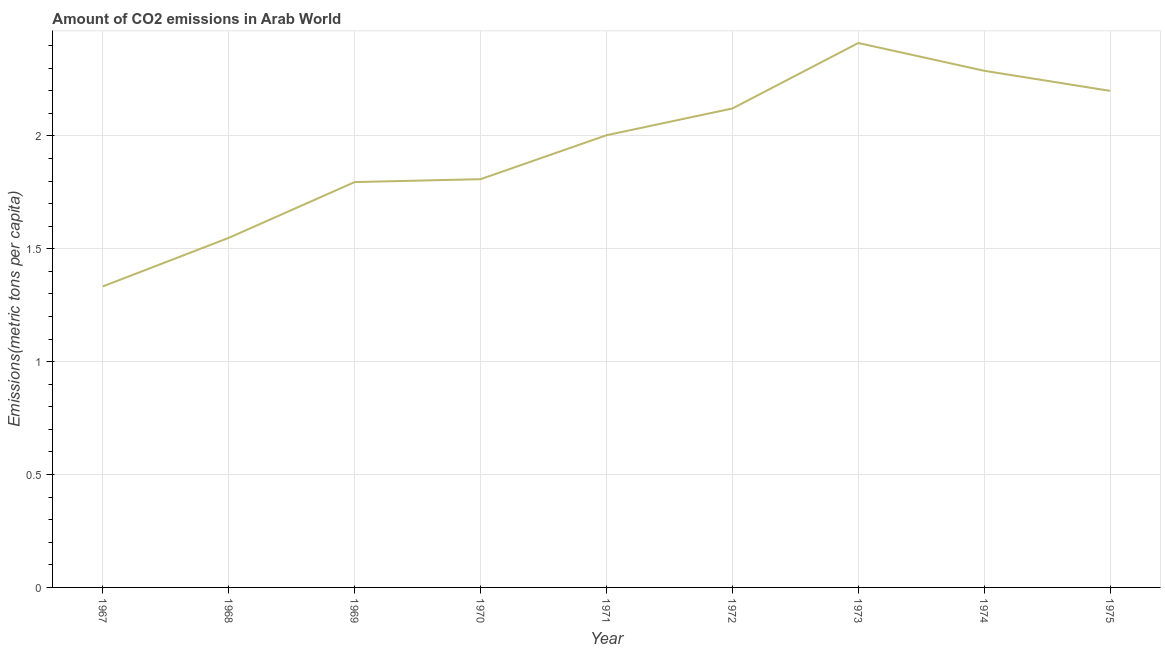What is the amount of co2 emissions in 1969?
Ensure brevity in your answer.  1.8. Across all years, what is the maximum amount of co2 emissions?
Keep it short and to the point. 2.41. Across all years, what is the minimum amount of co2 emissions?
Ensure brevity in your answer.  1.33. In which year was the amount of co2 emissions minimum?
Provide a succinct answer. 1967. What is the sum of the amount of co2 emissions?
Offer a terse response. 17.51. What is the difference between the amount of co2 emissions in 1972 and 1975?
Ensure brevity in your answer.  -0.08. What is the average amount of co2 emissions per year?
Ensure brevity in your answer.  1.95. What is the median amount of co2 emissions?
Your answer should be very brief. 2. In how many years, is the amount of co2 emissions greater than 1 metric tons per capita?
Your response must be concise. 9. What is the ratio of the amount of co2 emissions in 1970 to that in 1972?
Your answer should be compact. 0.85. Is the difference between the amount of co2 emissions in 1969 and 1970 greater than the difference between any two years?
Your answer should be compact. No. What is the difference between the highest and the second highest amount of co2 emissions?
Make the answer very short. 0.12. Is the sum of the amount of co2 emissions in 1967 and 1968 greater than the maximum amount of co2 emissions across all years?
Make the answer very short. Yes. What is the difference between the highest and the lowest amount of co2 emissions?
Provide a succinct answer. 1.08. In how many years, is the amount of co2 emissions greater than the average amount of co2 emissions taken over all years?
Provide a short and direct response. 5. Does the amount of co2 emissions monotonically increase over the years?
Make the answer very short. No. What is the difference between two consecutive major ticks on the Y-axis?
Offer a very short reply. 0.5. Does the graph contain grids?
Give a very brief answer. Yes. What is the title of the graph?
Provide a short and direct response. Amount of CO2 emissions in Arab World. What is the label or title of the X-axis?
Make the answer very short. Year. What is the label or title of the Y-axis?
Offer a very short reply. Emissions(metric tons per capita). What is the Emissions(metric tons per capita) in 1967?
Your response must be concise. 1.33. What is the Emissions(metric tons per capita) of 1968?
Your answer should be very brief. 1.55. What is the Emissions(metric tons per capita) in 1969?
Give a very brief answer. 1.8. What is the Emissions(metric tons per capita) of 1970?
Ensure brevity in your answer.  1.81. What is the Emissions(metric tons per capita) of 1971?
Make the answer very short. 2. What is the Emissions(metric tons per capita) in 1972?
Your response must be concise. 2.12. What is the Emissions(metric tons per capita) of 1973?
Provide a succinct answer. 2.41. What is the Emissions(metric tons per capita) of 1974?
Your answer should be compact. 2.29. What is the Emissions(metric tons per capita) in 1975?
Give a very brief answer. 2.2. What is the difference between the Emissions(metric tons per capita) in 1967 and 1968?
Make the answer very short. -0.22. What is the difference between the Emissions(metric tons per capita) in 1967 and 1969?
Keep it short and to the point. -0.46. What is the difference between the Emissions(metric tons per capita) in 1967 and 1970?
Provide a short and direct response. -0.47. What is the difference between the Emissions(metric tons per capita) in 1967 and 1971?
Provide a short and direct response. -0.67. What is the difference between the Emissions(metric tons per capita) in 1967 and 1972?
Give a very brief answer. -0.79. What is the difference between the Emissions(metric tons per capita) in 1967 and 1973?
Keep it short and to the point. -1.08. What is the difference between the Emissions(metric tons per capita) in 1967 and 1974?
Your answer should be very brief. -0.96. What is the difference between the Emissions(metric tons per capita) in 1967 and 1975?
Your response must be concise. -0.87. What is the difference between the Emissions(metric tons per capita) in 1968 and 1969?
Provide a short and direct response. -0.25. What is the difference between the Emissions(metric tons per capita) in 1968 and 1970?
Your response must be concise. -0.26. What is the difference between the Emissions(metric tons per capita) in 1968 and 1971?
Your answer should be very brief. -0.45. What is the difference between the Emissions(metric tons per capita) in 1968 and 1972?
Offer a very short reply. -0.57. What is the difference between the Emissions(metric tons per capita) in 1968 and 1973?
Offer a terse response. -0.86. What is the difference between the Emissions(metric tons per capita) in 1968 and 1974?
Your answer should be compact. -0.74. What is the difference between the Emissions(metric tons per capita) in 1968 and 1975?
Keep it short and to the point. -0.65. What is the difference between the Emissions(metric tons per capita) in 1969 and 1970?
Offer a terse response. -0.01. What is the difference between the Emissions(metric tons per capita) in 1969 and 1971?
Provide a short and direct response. -0.21. What is the difference between the Emissions(metric tons per capita) in 1969 and 1972?
Give a very brief answer. -0.33. What is the difference between the Emissions(metric tons per capita) in 1969 and 1973?
Ensure brevity in your answer.  -0.62. What is the difference between the Emissions(metric tons per capita) in 1969 and 1974?
Give a very brief answer. -0.49. What is the difference between the Emissions(metric tons per capita) in 1969 and 1975?
Ensure brevity in your answer.  -0.4. What is the difference between the Emissions(metric tons per capita) in 1970 and 1971?
Your answer should be very brief. -0.19. What is the difference between the Emissions(metric tons per capita) in 1970 and 1972?
Offer a very short reply. -0.31. What is the difference between the Emissions(metric tons per capita) in 1970 and 1973?
Provide a short and direct response. -0.6. What is the difference between the Emissions(metric tons per capita) in 1970 and 1974?
Your response must be concise. -0.48. What is the difference between the Emissions(metric tons per capita) in 1970 and 1975?
Keep it short and to the point. -0.39. What is the difference between the Emissions(metric tons per capita) in 1971 and 1972?
Provide a short and direct response. -0.12. What is the difference between the Emissions(metric tons per capita) in 1971 and 1973?
Keep it short and to the point. -0.41. What is the difference between the Emissions(metric tons per capita) in 1971 and 1974?
Ensure brevity in your answer.  -0.29. What is the difference between the Emissions(metric tons per capita) in 1971 and 1975?
Ensure brevity in your answer.  -0.2. What is the difference between the Emissions(metric tons per capita) in 1972 and 1973?
Your response must be concise. -0.29. What is the difference between the Emissions(metric tons per capita) in 1972 and 1974?
Offer a very short reply. -0.17. What is the difference between the Emissions(metric tons per capita) in 1972 and 1975?
Give a very brief answer. -0.08. What is the difference between the Emissions(metric tons per capita) in 1973 and 1974?
Provide a succinct answer. 0.12. What is the difference between the Emissions(metric tons per capita) in 1973 and 1975?
Make the answer very short. 0.21. What is the difference between the Emissions(metric tons per capita) in 1974 and 1975?
Offer a terse response. 0.09. What is the ratio of the Emissions(metric tons per capita) in 1967 to that in 1968?
Your answer should be very brief. 0.86. What is the ratio of the Emissions(metric tons per capita) in 1967 to that in 1969?
Provide a succinct answer. 0.74. What is the ratio of the Emissions(metric tons per capita) in 1967 to that in 1970?
Your response must be concise. 0.74. What is the ratio of the Emissions(metric tons per capita) in 1967 to that in 1971?
Offer a very short reply. 0.67. What is the ratio of the Emissions(metric tons per capita) in 1967 to that in 1972?
Offer a very short reply. 0.63. What is the ratio of the Emissions(metric tons per capita) in 1967 to that in 1973?
Offer a very short reply. 0.55. What is the ratio of the Emissions(metric tons per capita) in 1967 to that in 1974?
Provide a short and direct response. 0.58. What is the ratio of the Emissions(metric tons per capita) in 1967 to that in 1975?
Offer a terse response. 0.61. What is the ratio of the Emissions(metric tons per capita) in 1968 to that in 1969?
Offer a terse response. 0.86. What is the ratio of the Emissions(metric tons per capita) in 1968 to that in 1970?
Your answer should be very brief. 0.86. What is the ratio of the Emissions(metric tons per capita) in 1968 to that in 1971?
Offer a terse response. 0.77. What is the ratio of the Emissions(metric tons per capita) in 1968 to that in 1972?
Your answer should be very brief. 0.73. What is the ratio of the Emissions(metric tons per capita) in 1968 to that in 1973?
Make the answer very short. 0.64. What is the ratio of the Emissions(metric tons per capita) in 1968 to that in 1974?
Provide a short and direct response. 0.68. What is the ratio of the Emissions(metric tons per capita) in 1968 to that in 1975?
Keep it short and to the point. 0.7. What is the ratio of the Emissions(metric tons per capita) in 1969 to that in 1971?
Your answer should be compact. 0.9. What is the ratio of the Emissions(metric tons per capita) in 1969 to that in 1972?
Your answer should be compact. 0.85. What is the ratio of the Emissions(metric tons per capita) in 1969 to that in 1973?
Your response must be concise. 0.74. What is the ratio of the Emissions(metric tons per capita) in 1969 to that in 1974?
Keep it short and to the point. 0.79. What is the ratio of the Emissions(metric tons per capita) in 1969 to that in 1975?
Provide a short and direct response. 0.82. What is the ratio of the Emissions(metric tons per capita) in 1970 to that in 1971?
Your answer should be compact. 0.9. What is the ratio of the Emissions(metric tons per capita) in 1970 to that in 1972?
Your response must be concise. 0.85. What is the ratio of the Emissions(metric tons per capita) in 1970 to that in 1974?
Provide a succinct answer. 0.79. What is the ratio of the Emissions(metric tons per capita) in 1970 to that in 1975?
Give a very brief answer. 0.82. What is the ratio of the Emissions(metric tons per capita) in 1971 to that in 1972?
Your response must be concise. 0.94. What is the ratio of the Emissions(metric tons per capita) in 1971 to that in 1973?
Keep it short and to the point. 0.83. What is the ratio of the Emissions(metric tons per capita) in 1971 to that in 1974?
Offer a very short reply. 0.88. What is the ratio of the Emissions(metric tons per capita) in 1971 to that in 1975?
Provide a short and direct response. 0.91. What is the ratio of the Emissions(metric tons per capita) in 1972 to that in 1974?
Offer a terse response. 0.93. What is the ratio of the Emissions(metric tons per capita) in 1972 to that in 1975?
Your response must be concise. 0.96. What is the ratio of the Emissions(metric tons per capita) in 1973 to that in 1974?
Offer a terse response. 1.05. What is the ratio of the Emissions(metric tons per capita) in 1973 to that in 1975?
Give a very brief answer. 1.1. What is the ratio of the Emissions(metric tons per capita) in 1974 to that in 1975?
Provide a short and direct response. 1.04. 